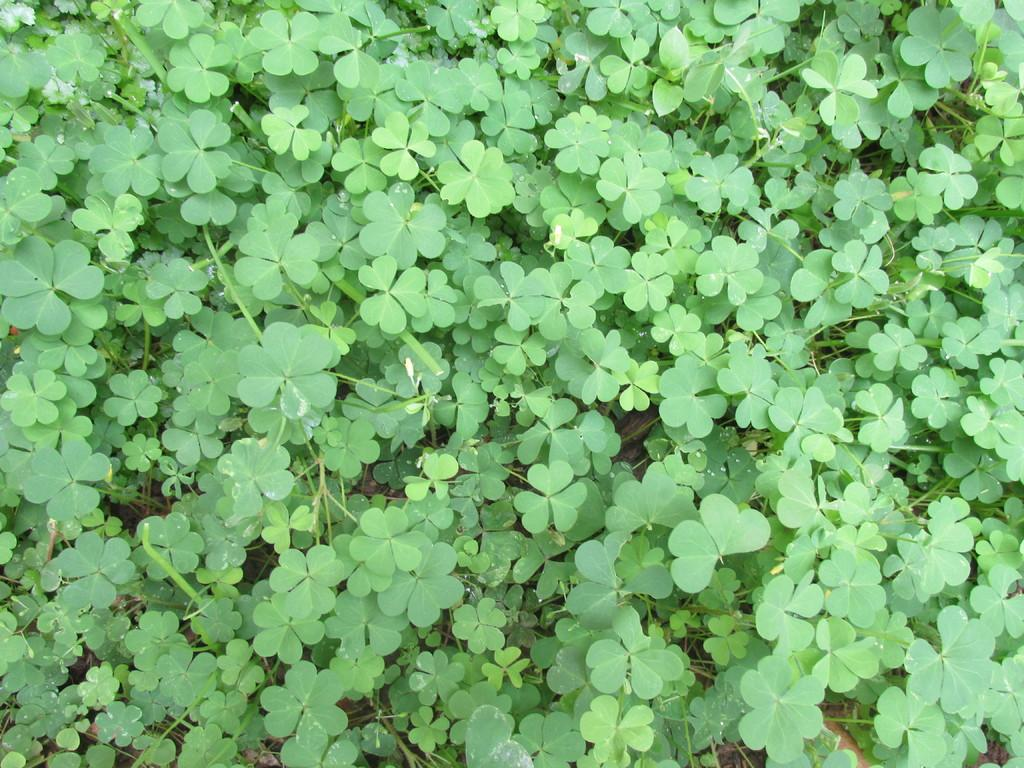What type of living organisms can be seen in the image? Plants can be seen in the image. What size sweater is the plant wearing in the image? There is no sweater present in the image, as plants do not wear clothing. 